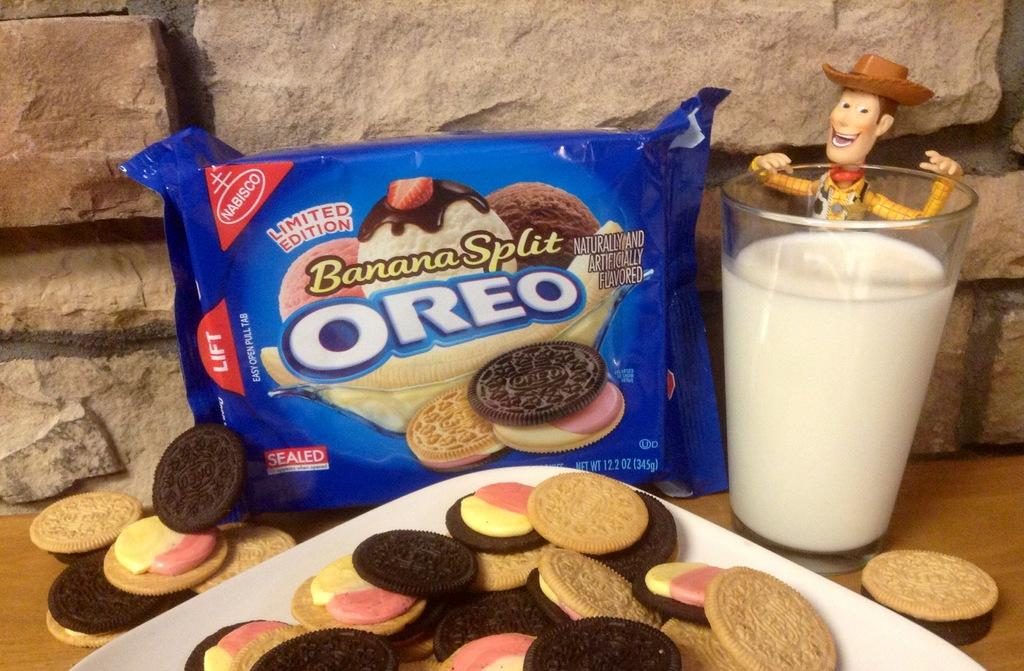What is located in the foreground of the picture? In the foreground of the picture, there are biscuits, milk in a glass, a toy, a biscuit packet, a table, and a stone wall. What type of food is visible in the foreground of the picture? Biscuits and milk in a glass are visible in the foreground of the picture. What object is associated with the biscuits in the foreground of the picture? There is a biscuit packet in the foreground of the picture. What type of surface is present in the foreground of the picture? There is a table in the foreground of the picture. What type of structure is visible in the foreground of the picture? A stone wall is visible in the foreground of the picture. How does the zebra interact with the biscuits in the foreground of the picture? There is no zebra present in the image, so it cannot interact with the biscuits. What type of rubbing motion is used to clean the toy in the foreground of the picture? There is no rubbing motion or cleaning activity depicted in the image; the toy is simply present in the foreground. 